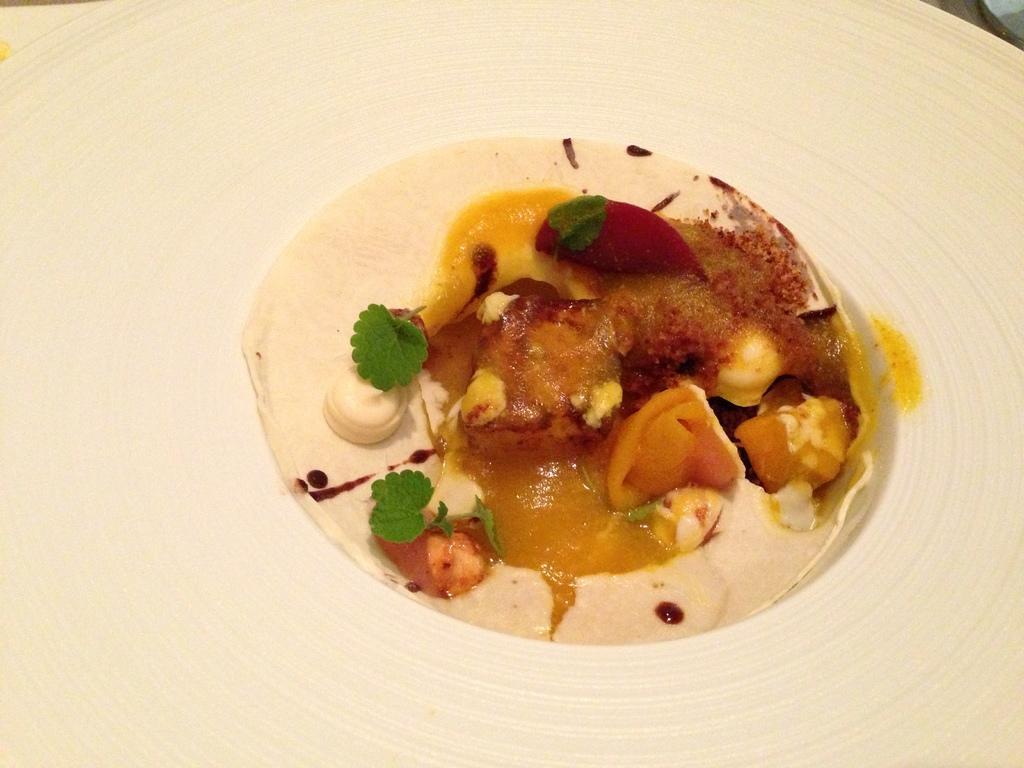Can you describe this image briefly? In the picture I can see some food item is placed on the white color surface. 